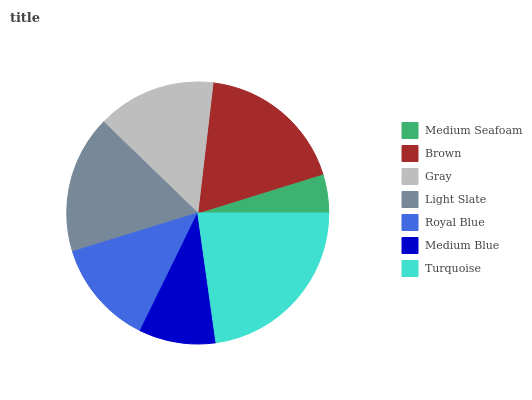Is Medium Seafoam the minimum?
Answer yes or no. Yes. Is Turquoise the maximum?
Answer yes or no. Yes. Is Brown the minimum?
Answer yes or no. No. Is Brown the maximum?
Answer yes or no. No. Is Brown greater than Medium Seafoam?
Answer yes or no. Yes. Is Medium Seafoam less than Brown?
Answer yes or no. Yes. Is Medium Seafoam greater than Brown?
Answer yes or no. No. Is Brown less than Medium Seafoam?
Answer yes or no. No. Is Gray the high median?
Answer yes or no. Yes. Is Gray the low median?
Answer yes or no. Yes. Is Turquoise the high median?
Answer yes or no. No. Is Brown the low median?
Answer yes or no. No. 